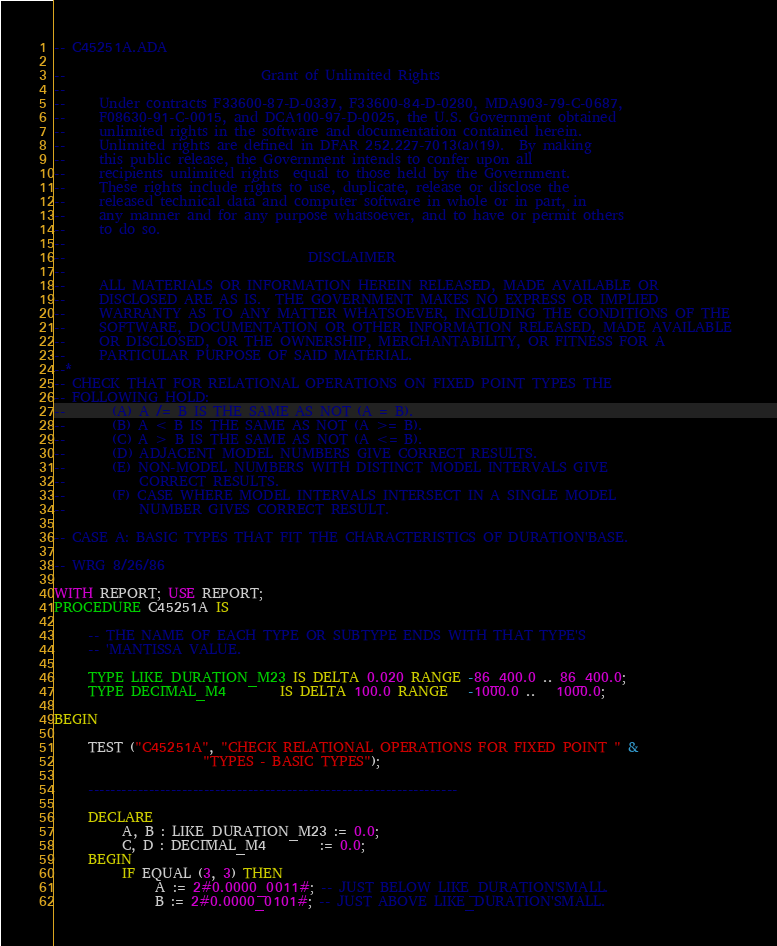<code> <loc_0><loc_0><loc_500><loc_500><_Ada_>-- C45251A.ADA

--                             Grant of Unlimited Rights
--
--     Under contracts F33600-87-D-0337, F33600-84-D-0280, MDA903-79-C-0687,
--     F08630-91-C-0015, and DCA100-97-D-0025, the U.S. Government obtained 
--     unlimited rights in the software and documentation contained herein.
--     Unlimited rights are defined in DFAR 252.227-7013(a)(19).  By making 
--     this public release, the Government intends to confer upon all 
--     recipients unlimited rights  equal to those held by the Government.  
--     These rights include rights to use, duplicate, release or disclose the 
--     released technical data and computer software in whole or in part, in 
--     any manner and for any purpose whatsoever, and to have or permit others 
--     to do so.
--
--                                    DISCLAIMER
--
--     ALL MATERIALS OR INFORMATION HEREIN RELEASED, MADE AVAILABLE OR
--     DISCLOSED ARE AS IS.  THE GOVERNMENT MAKES NO EXPRESS OR IMPLIED 
--     WARRANTY AS TO ANY MATTER WHATSOEVER, INCLUDING THE CONDITIONS OF THE
--     SOFTWARE, DOCUMENTATION OR OTHER INFORMATION RELEASED, MADE AVAILABLE 
--     OR DISCLOSED, OR THE OWNERSHIP, MERCHANTABILITY, OR FITNESS FOR A
--     PARTICULAR PURPOSE OF SAID MATERIAL.
--*
-- CHECK THAT FOR RELATIONAL OPERATIONS ON FIXED POINT TYPES THE
-- FOLLOWING HOLD:
--       (A) A /= B IS THE SAME AS NOT (A = B).
--       (B) A < B IS THE SAME AS NOT (A >= B).
--       (C) A > B IS THE SAME AS NOT (A <= B).
--       (D) ADJACENT MODEL NUMBERS GIVE CORRECT RESULTS.
--       (E) NON-MODEL NUMBERS WITH DISTINCT MODEL INTERVALS GIVE
--           CORRECT RESULTS.
--       (F) CASE WHERE MODEL INTERVALS INTERSECT IN A SINGLE MODEL
--           NUMBER GIVES CORRECT RESULT.

-- CASE A: BASIC TYPES THAT FIT THE CHARACTERISTICS OF DURATION'BASE.

-- WRG 8/26/86

WITH REPORT; USE REPORT;
PROCEDURE C45251A IS

     -- THE NAME OF EACH TYPE OR SUBTYPE ENDS WITH THAT TYPE'S
     -- 'MANTISSA VALUE.

     TYPE LIKE_DURATION_M23 IS DELTA 0.020 RANGE -86_400.0 .. 86_400.0;
     TYPE DECIMAL_M4        IS DELTA 100.0 RANGE   -1000.0 ..   1000.0;

BEGIN

     TEST ("C45251A", "CHECK RELATIONAL OPERATIONS FOR FIXED POINT " &
                      "TYPES - BASIC TYPES");

     -------------------------------------------------------------------

     DECLARE
          A, B : LIKE_DURATION_M23 := 0.0;
          C, D : DECIMAL_M4        := 0.0;
     BEGIN
          IF EQUAL (3, 3) THEN
               A := 2#0.0000_0011#; -- JUST BELOW LIKE_DURATION'SMALL.
               B := 2#0.0000_0101#; -- JUST ABOVE LIKE_DURATION'SMALL.</code> 